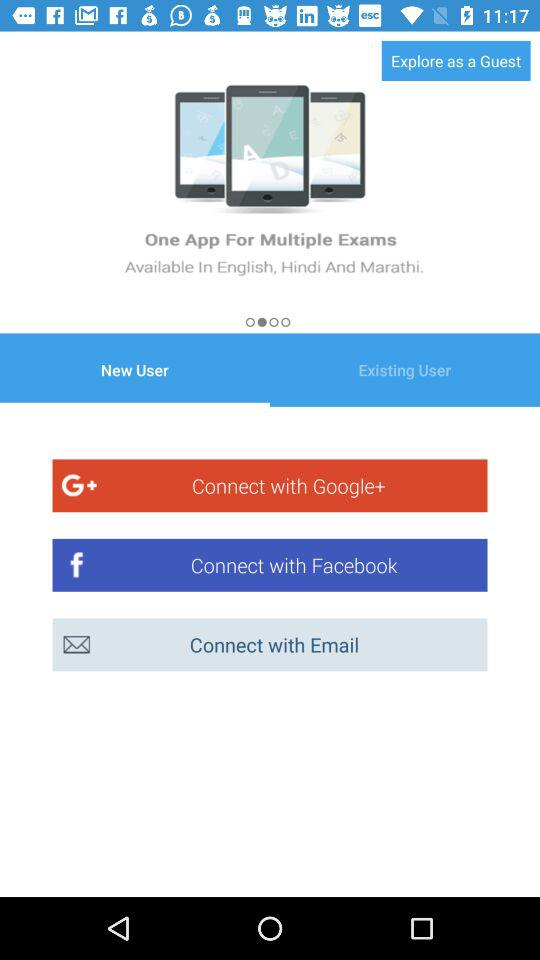In what languages is the application available? The application is available in English, Hindi, and Marathi. 